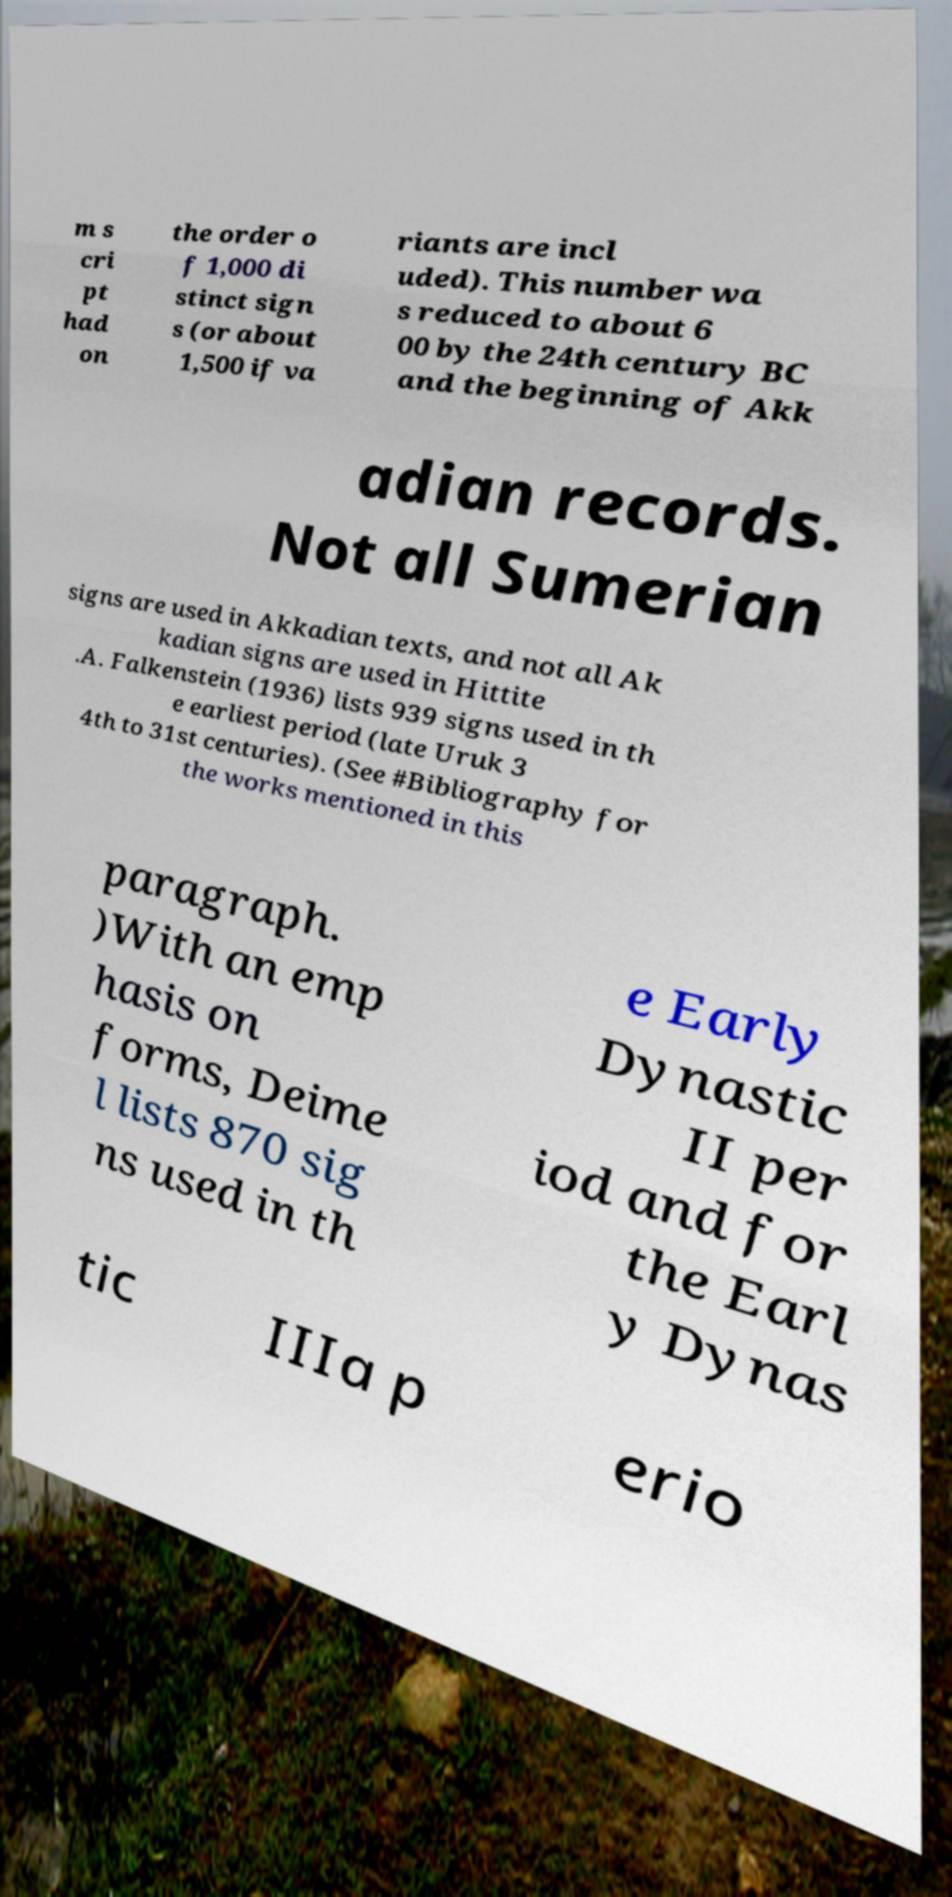There's text embedded in this image that I need extracted. Can you transcribe it verbatim? m s cri pt had on the order o f 1,000 di stinct sign s (or about 1,500 if va riants are incl uded). This number wa s reduced to about 6 00 by the 24th century BC and the beginning of Akk adian records. Not all Sumerian signs are used in Akkadian texts, and not all Ak kadian signs are used in Hittite .A. Falkenstein (1936) lists 939 signs used in th e earliest period (late Uruk 3 4th to 31st centuries). (See #Bibliography for the works mentioned in this paragraph. )With an emp hasis on forms, Deime l lists 870 sig ns used in th e Early Dynastic II per iod and for the Earl y Dynas tic IIIa p erio 